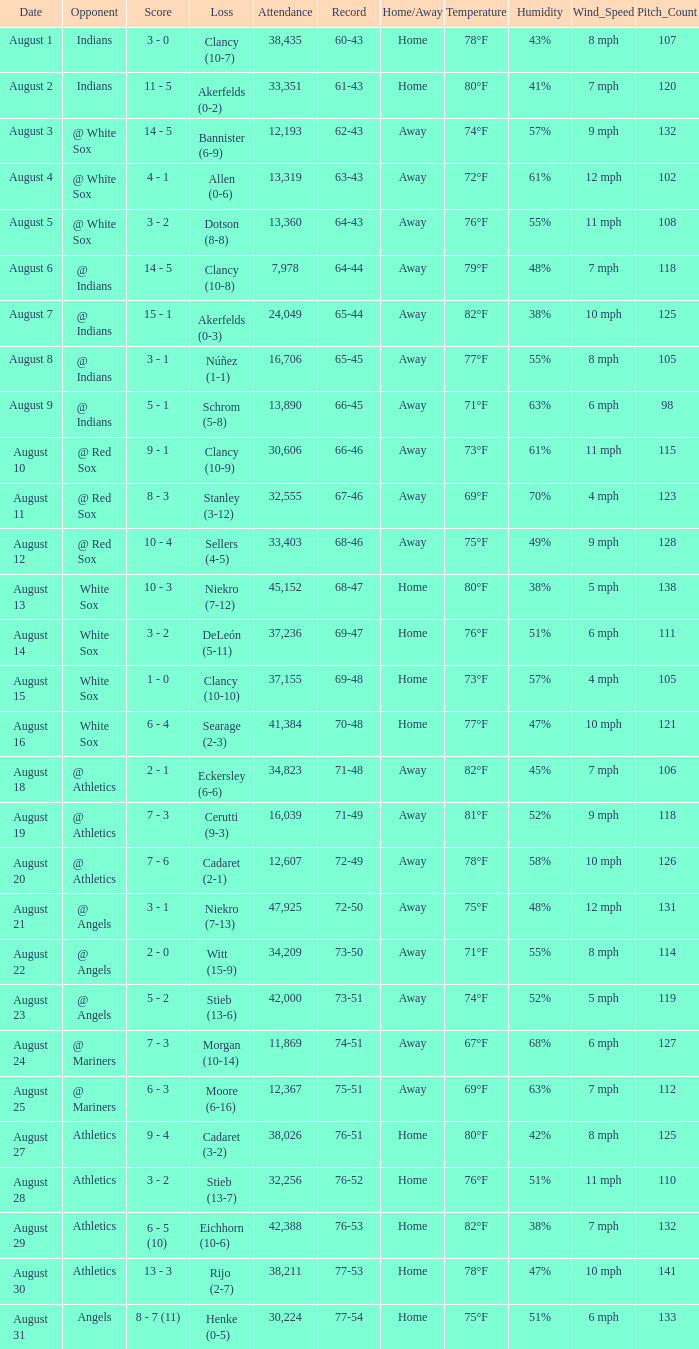What was the attendance when the record was 77-54? 30224.0. 